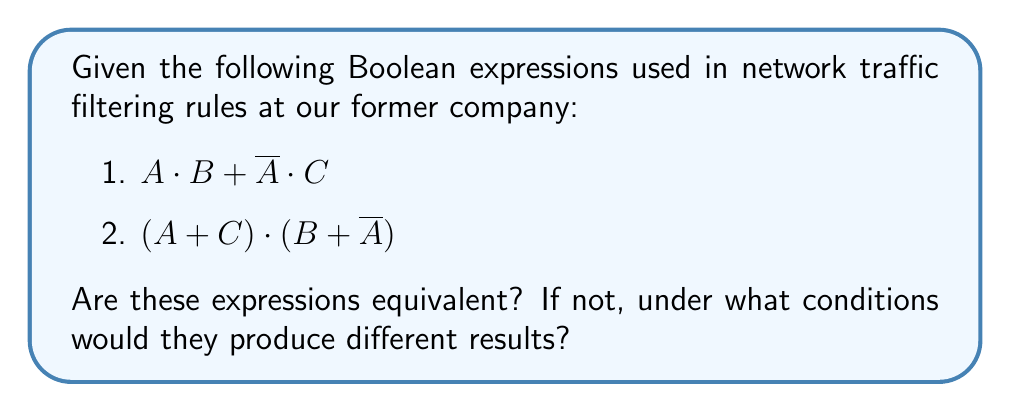Help me with this question. Let's evaluate the equivalence of these two Boolean expressions step by step:

1. First, let's expand the second expression:
   $$(A + C) \cdot (B + \overline{A})$$
   $$= AB + A\overline{A} + CB + C\overline{A}$$
   $$= AB + 0 + CB + C\overline{A}$$ (since $A\overline{A} = 0$)
   $$= AB + CB + C\overline{A}$$

2. Now, let's factor out $B$ from the first two terms:
   $$= B(A + C) + C\overline{A}$$

3. Distribute $C$:
   $$= BA + BC + C\overline{A}$$

4. Rearrange terms:
   $$= AB + BC + C\overline{A}$$

5. Now, let's compare this to the first expression:
   $$A \cdot B + \overline{A} \cdot C$$
   $$= AB + \overline{A}C$$

6. We can see that these expressions are not equivalent. The second expression has an additional term $BC$.

7. The expressions will produce different results when $A$ is false (0), $B$ is true (1), and $C$ is true (1):
   - For the first expression: $0 \cdot 1 + 1 \cdot 1 = 0 + 1 = 1$
   - For the second expression: $1 \cdot 1 + 1 \cdot 1 + 1 \cdot 1 = 1 + 1 + 1 = 1$

   In this case, both expressions evaluate to 1, but through different paths.

8. They will also produce different results when $A$ is true (1), $B$ is true (1), and $C$ is true (1):
   - For the first expression: $1 \cdot 1 + 0 \cdot 1 = 1 + 0 = 1$
   - For the second expression: $1 \cdot 1 + 1 \cdot 1 + 0 \cdot 1 = 1 + 1 + 0 = 1$

   Again, both expressions evaluate to 1, but the second expression includes an additional true term.
Answer: Not equivalent; differ when $B=1$ and $C=1$, regardless of $A$. 